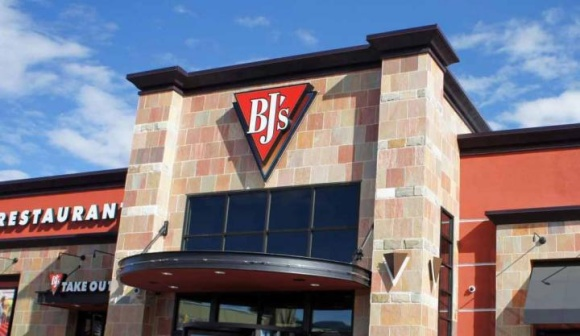What are the key elements in this picture? The image captures a moment at a BJ's Restaurant and Brewhouse. The building, constructed of brick, stands under a clear blue sky with a smattering of clouds. Dominating the front of the building is a large logo, a triangle in red and black with the letters "BJ's" emblazoned in white. The entrance to the restaurant is sheltered by a curved awning, inviting patrons in. On either side of the entrance, signs indicate the dual nature of the establishment - "Restaurant" to the left and "Take Out" to the right. The image paints a picture of a bustling eatery, ready to serve its customers. 